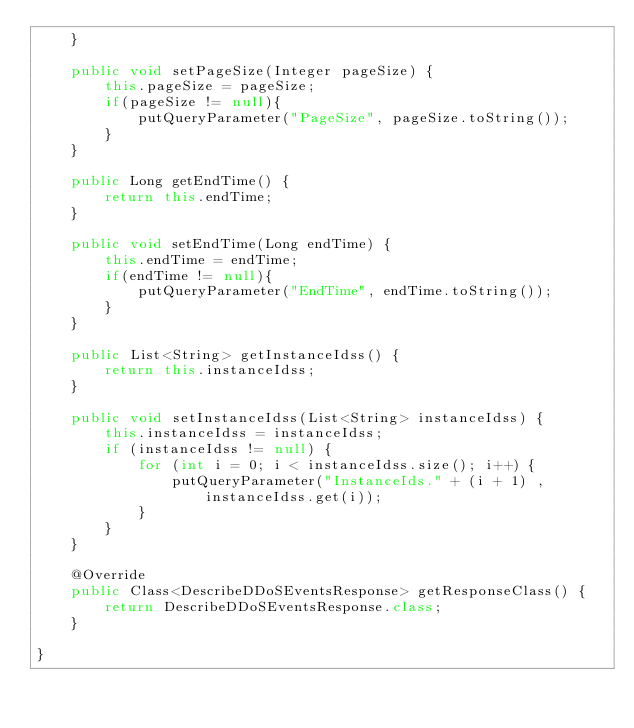<code> <loc_0><loc_0><loc_500><loc_500><_Java_>	}

	public void setPageSize(Integer pageSize) {
		this.pageSize = pageSize;
		if(pageSize != null){
			putQueryParameter("PageSize", pageSize.toString());
		}
	}

	public Long getEndTime() {
		return this.endTime;
	}

	public void setEndTime(Long endTime) {
		this.endTime = endTime;
		if(endTime != null){
			putQueryParameter("EndTime", endTime.toString());
		}
	}

	public List<String> getInstanceIdss() {
		return this.instanceIdss;
	}

	public void setInstanceIdss(List<String> instanceIdss) {
		this.instanceIdss = instanceIdss;	
		if (instanceIdss != null) {
			for (int i = 0; i < instanceIdss.size(); i++) {
				putQueryParameter("InstanceIds." + (i + 1) , instanceIdss.get(i));
			}
		}	
	}

	@Override
	public Class<DescribeDDoSEventsResponse> getResponseClass() {
		return DescribeDDoSEventsResponse.class;
	}

}
</code> 